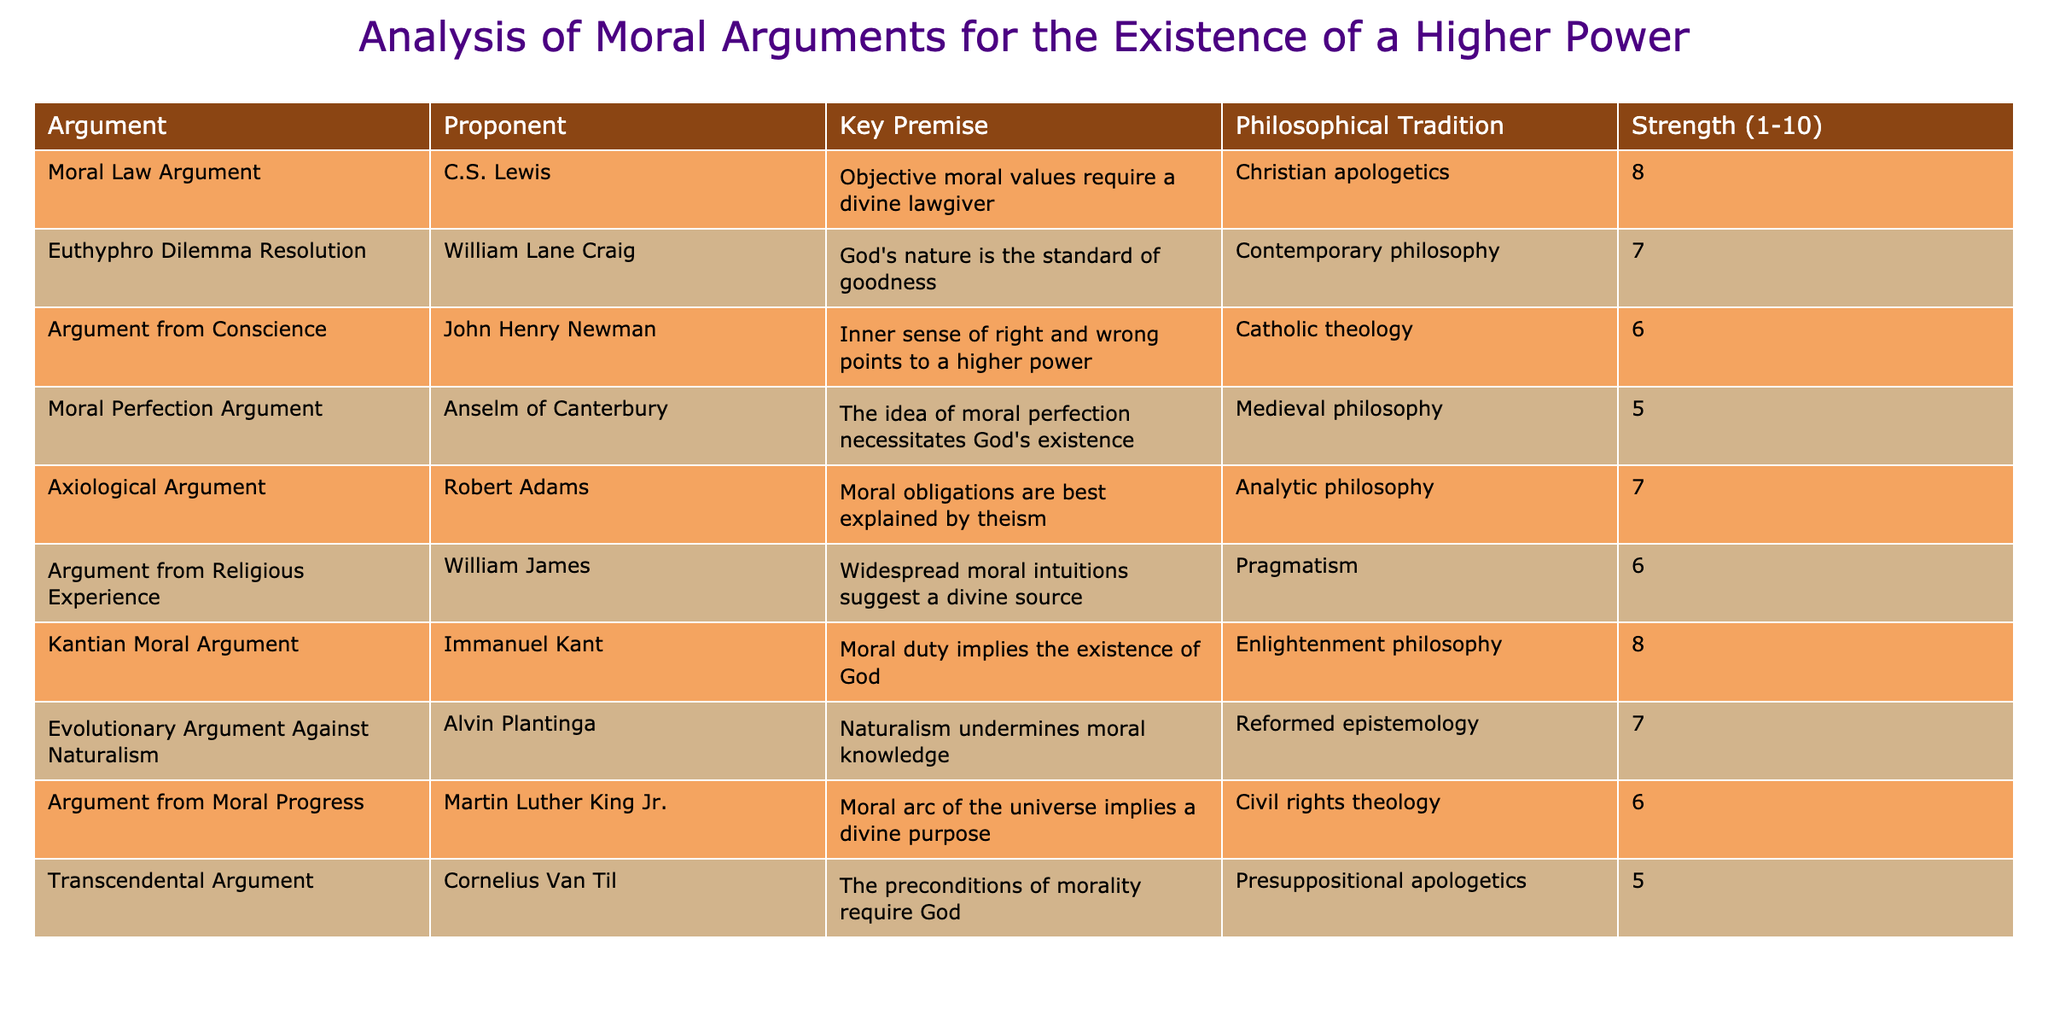What is the highest strength rating among the arguments presented? By examining the "Strength (1-10)" column, the highest value listed is 8. This corresponds to two arguments: the Moral Law Argument and the Kantian Moral Argument.
Answer: 8 Which philosopher proposed the Argument from Conscience? The table lists John Henry Newman as the proponent of the Argument from Conscience, indicating he advocates for this specific moral argument.
Answer: John Henry Newman What is the average strength rating of all the arguments presented? To find the average, sum all strength ratings: (8 + 7 + 6 + 5 + 7 + 6 + 8 + 7 + 6 + 5) = 59. There are 10 arguments, so the average strength rating is 59/10 = 5.9.
Answer: 5.9 Does the Euthyphro Dilemma Resolution argument suggest that moral standards are independent of God? The argument, as stated, claims that God's nature is the standard of goodness, implying that moral standards are not independent but derived from God. Thus, the answer is no.
Answer: No How many arguments are associated with the philosophical tradition of Christian apologetics? There are two arguments listed under Christian apologetics: the Moral Law Argument and the Axiological Argument, making a total of two arguments in this category.
Answer: 2 What is the difference in strength rating between the Argument from Moral Progress and the Moral Perfection Argument? The strength rating of the Argument from Moral Progress is 6, while the Moral Perfection Argument has a strength rating of 5. The difference is 6 - 5 = 1.
Answer: 1 Is the Argument from Religious Experience considered stronger than the Argument from Moral Progress? The strength of the Argument from Religious Experience is 6, which is equal to the strength of the Argument from Moral Progress, which is also 6. Thus, the argument from Religious Experience is not stronger.
Answer: No Which philosophical tradition has the highest average strength rating based on the arguments under it? Analyzing the arguments: Christian apologetics (average is (8+7)/2 = 7.5), Contemporary philosophy (7), Catholic theology (6), Medieval philosophy (5), Analytic philosophy (7), Pragmatism (6), Enlightenment philosophy (8), Reformed epistemology (7), Civil rights theology (6), and Presuppositional apologetics (5). The tradition with the highest average is Christian apologetics (7.5).
Answer: Christian apologetics 